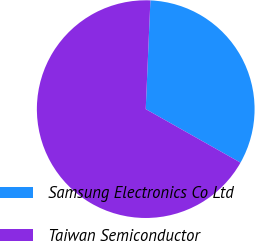Convert chart. <chart><loc_0><loc_0><loc_500><loc_500><pie_chart><fcel>Samsung Electronics Co Ltd<fcel>Taiwan Semiconductor<nl><fcel>32.5%<fcel>67.5%<nl></chart> 